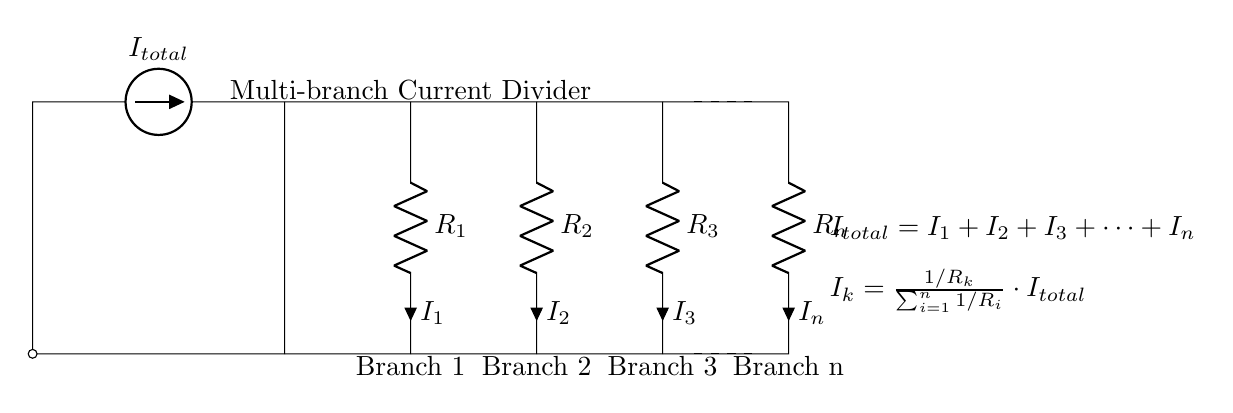What is the total current in the circuit? The total current is denoted as I_total in the circuit diagram and is shown as the current coming from the current source.
Answer: I_total What are the values of the resistors? The resistors are represented as R_1, R_2, R_3, and R_n in the diagram, but their numerical values are not specified in the circuit diagram itself.
Answer: R_1, R_2, R_3, R_n How many branches are there in the current divider? The circuit shows five branches, including the main branch and the four resistance branches.
Answer: Four What is the formula for calculating the current in branch k? The formula for finding the current in branch k is displayed in the diagram, explaining how the current for each branch is calculated proportionally based on resistance.
Answer: I_k = (1/R_k) / (sum of 1/R_i) * I_total Which branch has the highest current? The current in each branch depends on the resistance values; thus, the branch with the smallest resistance would have the highest current. This requires knowledge of specific resistor values to determine definitively.
Answer: Depends on values What does the dashed line represent in the diagram? The dashed lines in the circuit diagram indicate distance or separation between different sections of the circuit, but do not represent any components or connections.
Answer: Separation What is the relationship between the currents in the branches? The relationship is expressed in the equation I_total = I_1 + I_2 + I_3 + ... + I_n, indicating that the total current is the sum of the currents flowing through each branch.
Answer: They sum to I_total 